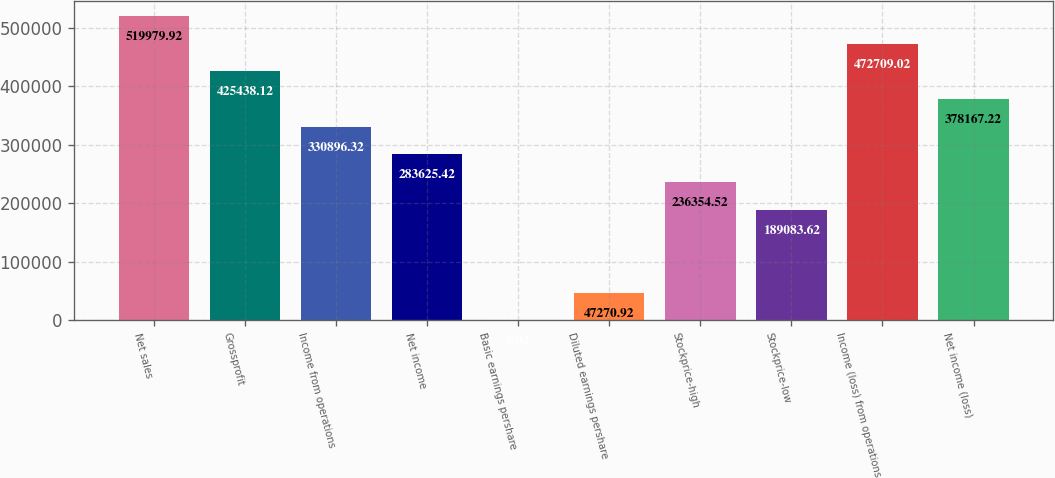Convert chart to OTSL. <chart><loc_0><loc_0><loc_500><loc_500><bar_chart><fcel>Net sales<fcel>Grossprofit<fcel>Income from operations<fcel>Net income<fcel>Basic earnings pershare<fcel>Diluted earnings pershare<fcel>Stockprice-high<fcel>Stockprice-low<fcel>Income (loss) from operations<fcel>Net income (loss)<nl><fcel>519980<fcel>425438<fcel>330896<fcel>283625<fcel>0.02<fcel>47270.9<fcel>236355<fcel>189084<fcel>472709<fcel>378167<nl></chart> 